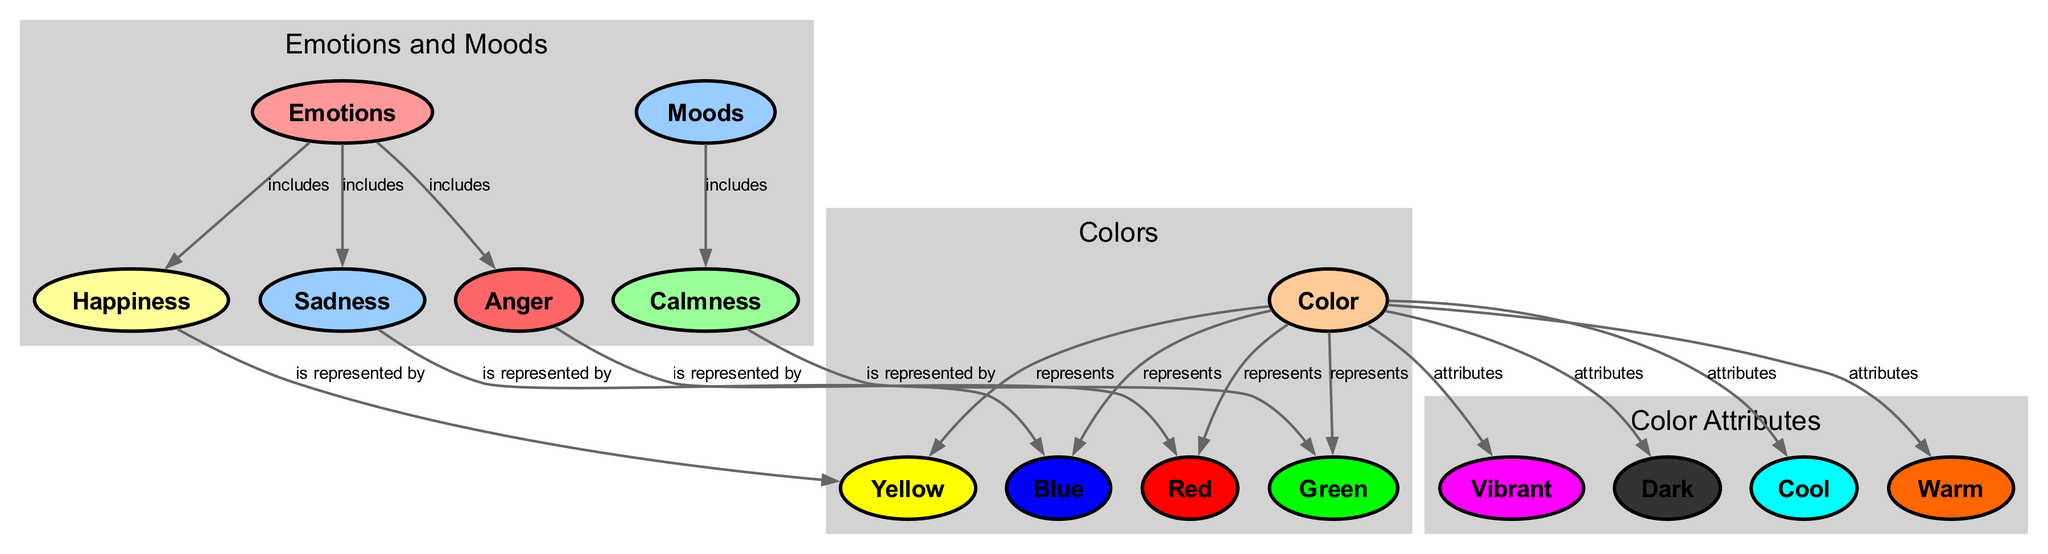What are the four emotions included in the diagram? The diagram has a node labeled "emotions," which connects to four specific emotions: happiness, sadness, anger, and calmness. Therefore, by listing these connections, I can identify the four emotions included in it.
Answer: happiness, sadness, anger, calmness Which color is represented by sadness? The diagram shows a direct connection from the "sadness" node to the "blue" node, with the label "is represented by." This indicates that the specific color that represents sadness is blue.
Answer: blue How many color attributes are listed in the diagram? The color attributes, seen in their own cluster, are vibrant, dark, cool, and warm. Since there are four distinct attributes connected to the color node, I can conclude that the total number is four.
Answer: 4 What color represents calmness? The diagram connects the "calmness" node to the "green" node with the label "is represented by." This tells me that the specific color connected to calmness is green.
Answer: green Which emotion is represented by the color red? According to the diagram, the "anger" node connects to the "red" node with the label "is represented by." This indicates that the emotion of anger is represented by red.
Answer: anger What nodes connect to the "emotions" node? The "emotions" node connects to three distinct emotions: happiness, sadness, and anger. Each of these nodes pair with the "emotions" node with the label "includes," helping me identify the connected nodes.
Answer: happiness, sadness, anger How many distinct colors are shown in the diagram? There are four colors listed: yellow, blue, red, and green. Since these colors directly connect to the "color" node based on their attributes, I count a total of four distinct colors displayed in the diagram.
Answer: 4 What label describes the relationship between "color" and "yellow"? The diagram indicates a direct relationship from the "color" node to the "yellow" node, labeled as "represents." This shows how the color yellow relates structurally to the concept of color in the diagram.
Answer: represents What mood includes calmness as a component? Looking at the mood cluster in the diagram, calmness is the only mood listed, meaning it is also included in the moods node connected through the label "includes."
Answer: calmness 